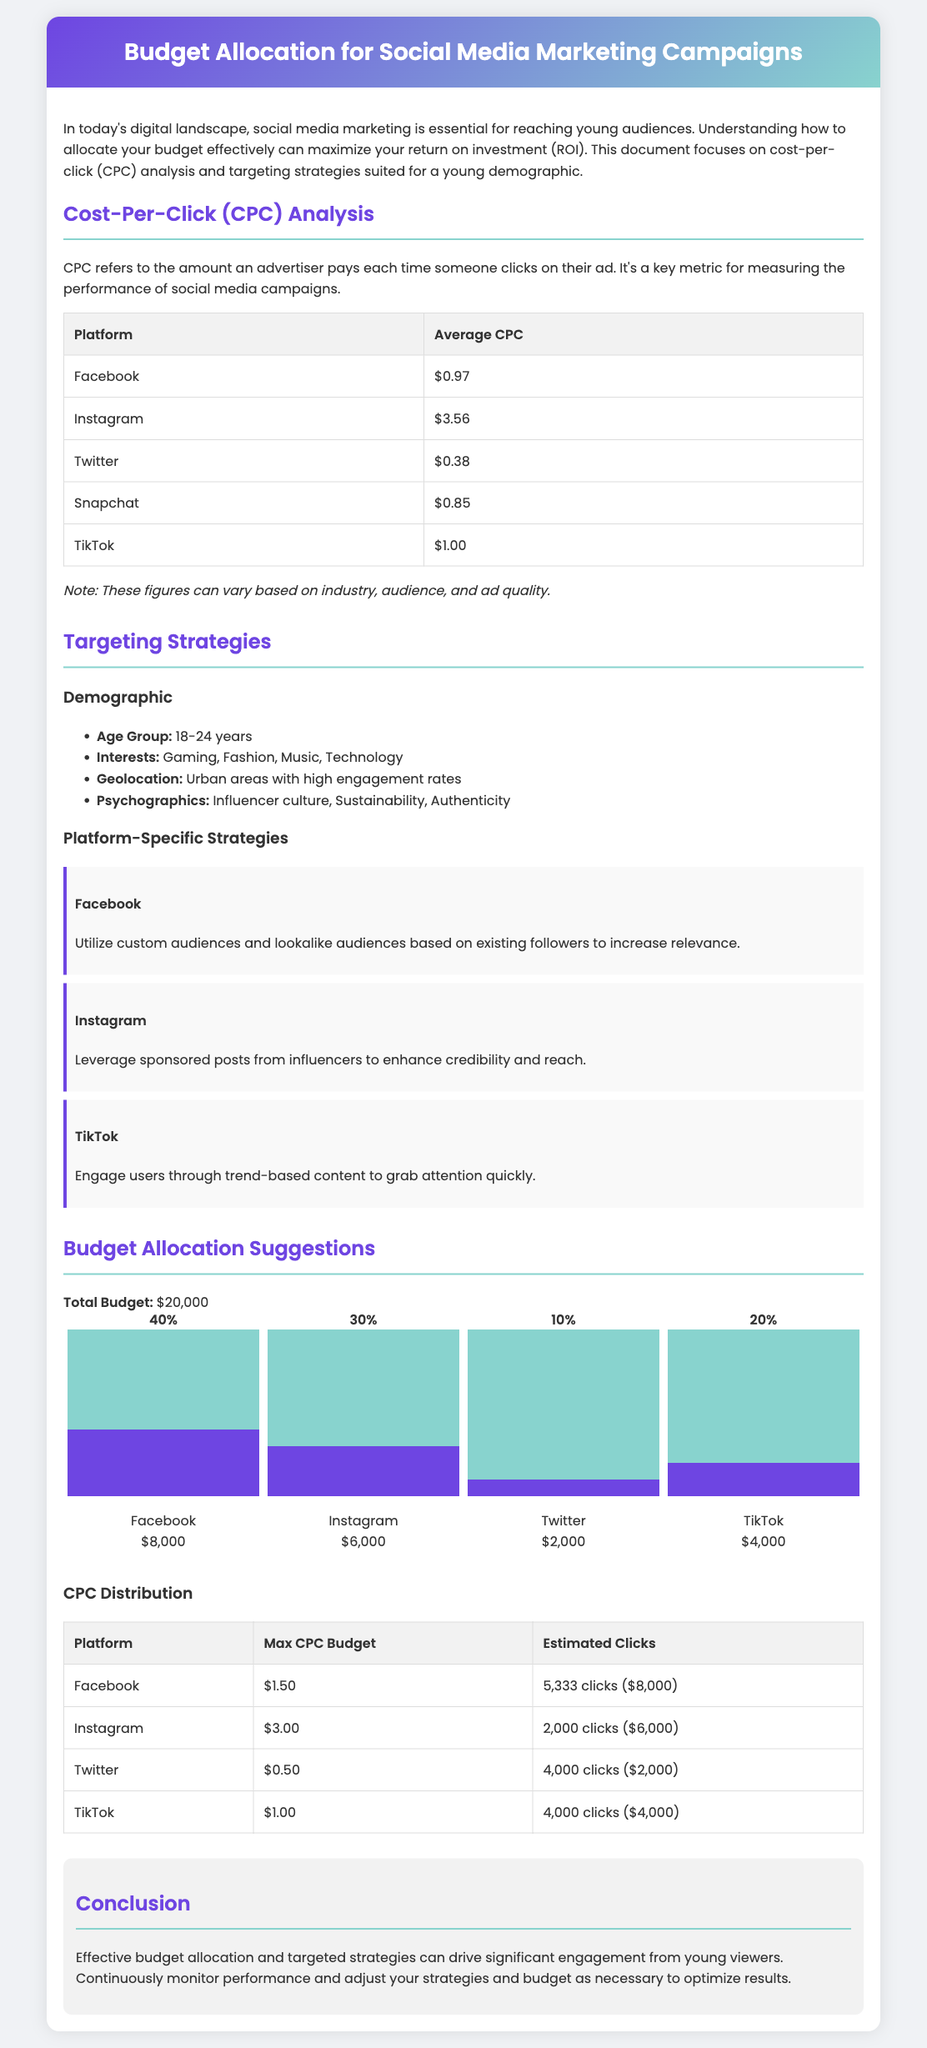What is the average CPC on Facebook? The document states that the average CPC on Facebook is listed in the table under the CPC Analysis section.
Answer: $0.97 What percentage of the total budget is allocated to Instagram? The total budget is broken down in the budget allocation section, showing Instagram's allocation.
Answer: 30% How many estimated clicks can be gained from the budget allocated to Twitter? The estimated clicks from Twitter are shown in the CPC Distribution table based on its budget and CPC.
Answer: 4,000 clicks What is the total budget for the social media marketing campaign? The total budget is stated explicitly in the budget allocation section at the beginning.
Answer: $20,000 Which platform has the highest average CPC? The average CPCs for each platform are compared in the CPC Analysis section to determine which is the highest.
Answer: Instagram 